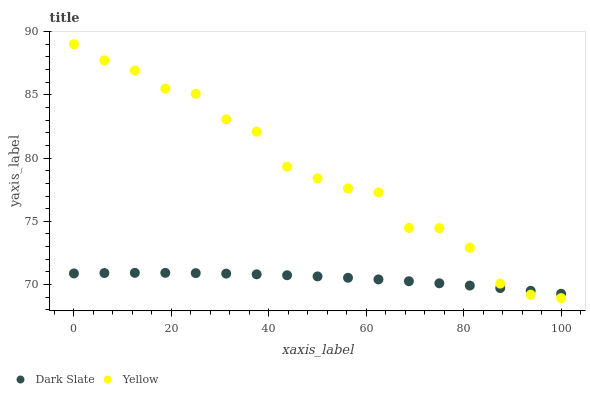Does Dark Slate have the minimum area under the curve?
Answer yes or no. Yes. Does Yellow have the maximum area under the curve?
Answer yes or no. Yes. Does Yellow have the minimum area under the curve?
Answer yes or no. No. Is Dark Slate the smoothest?
Answer yes or no. Yes. Is Yellow the roughest?
Answer yes or no. Yes. Is Yellow the smoothest?
Answer yes or no. No. Does Yellow have the lowest value?
Answer yes or no. Yes. Does Yellow have the highest value?
Answer yes or no. Yes. Does Dark Slate intersect Yellow?
Answer yes or no. Yes. Is Dark Slate less than Yellow?
Answer yes or no. No. Is Dark Slate greater than Yellow?
Answer yes or no. No. 